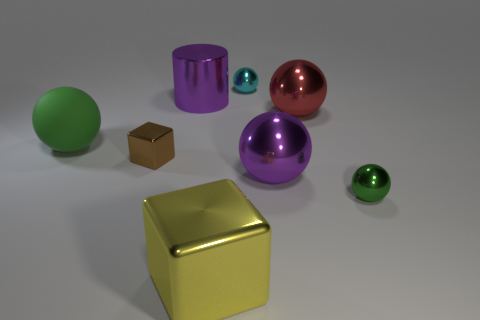Subtract all small green spheres. How many spheres are left? 4 Subtract all purple spheres. How many spheres are left? 4 Subtract all brown balls. Subtract all yellow cubes. How many balls are left? 5 Add 2 tiny cyan cylinders. How many objects exist? 10 Subtract all balls. How many objects are left? 3 Subtract 0 red cylinders. How many objects are left? 8 Subtract all small green metallic spheres. Subtract all red spheres. How many objects are left? 6 Add 7 big purple metal cylinders. How many big purple metal cylinders are left? 8 Add 5 green rubber things. How many green rubber things exist? 6 